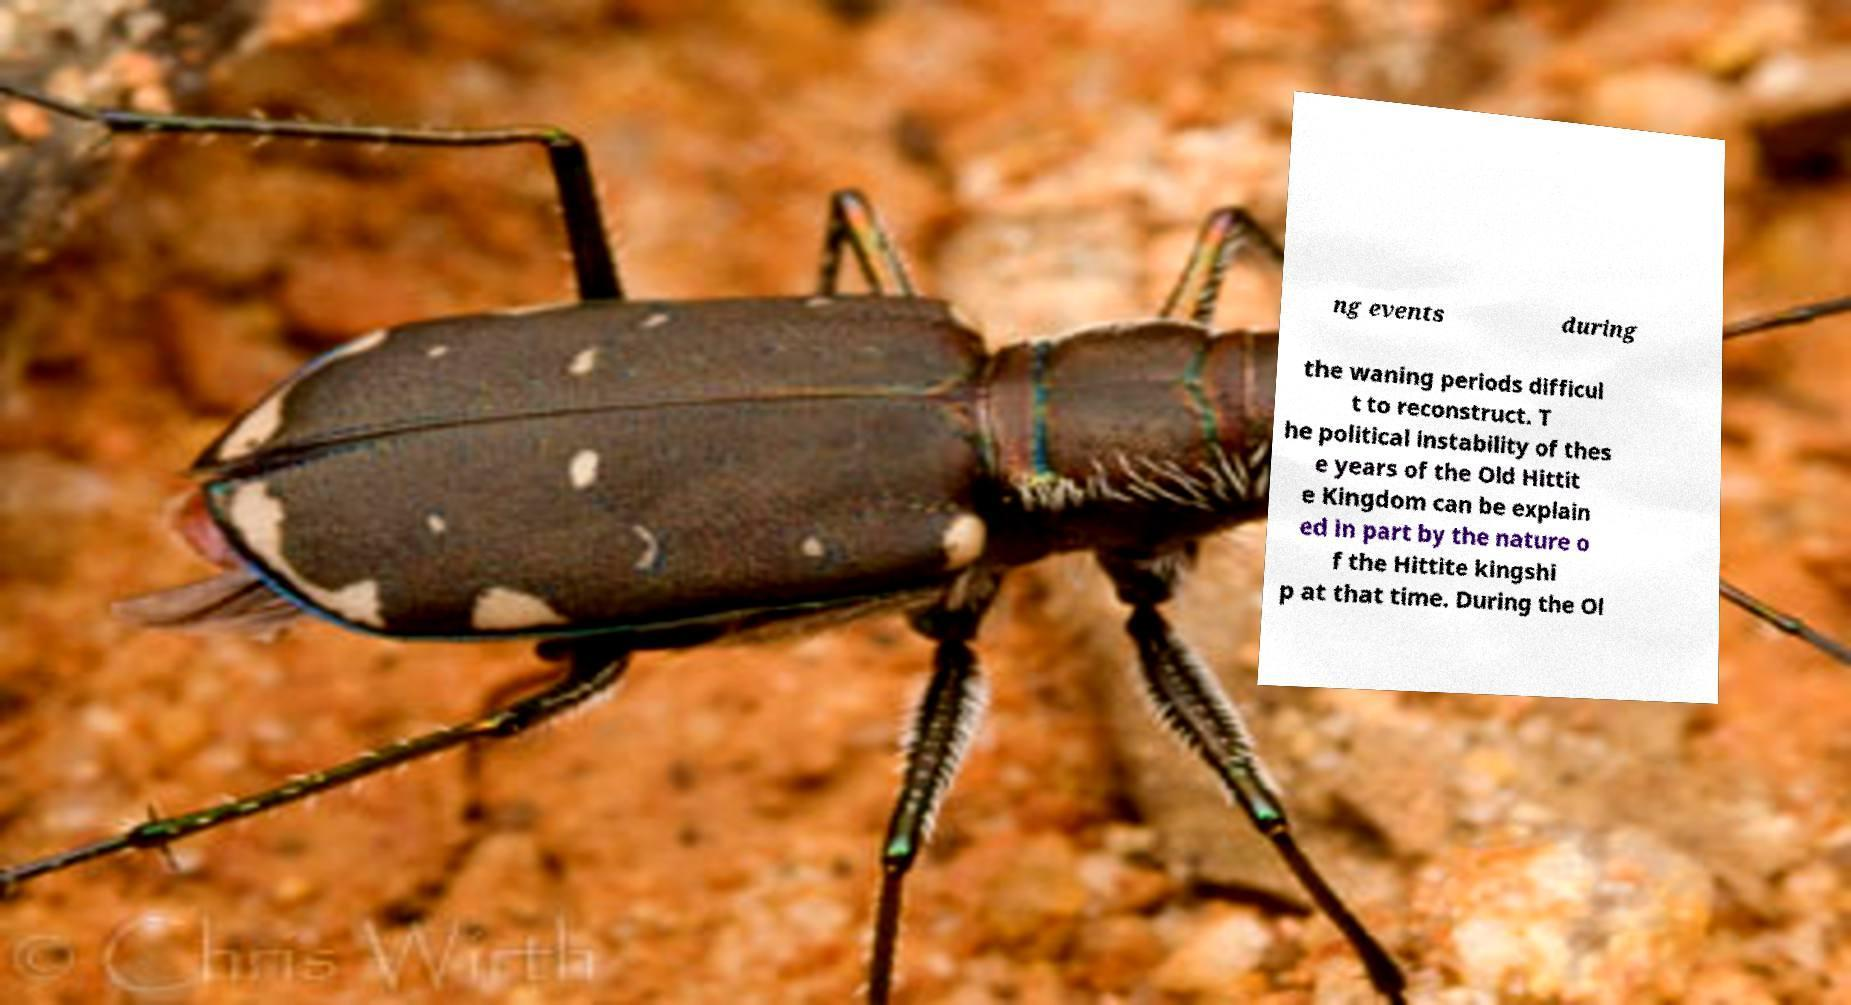There's text embedded in this image that I need extracted. Can you transcribe it verbatim? ng events during the waning periods difficul t to reconstruct. T he political instability of thes e years of the Old Hittit e Kingdom can be explain ed in part by the nature o f the Hittite kingshi p at that time. During the Ol 